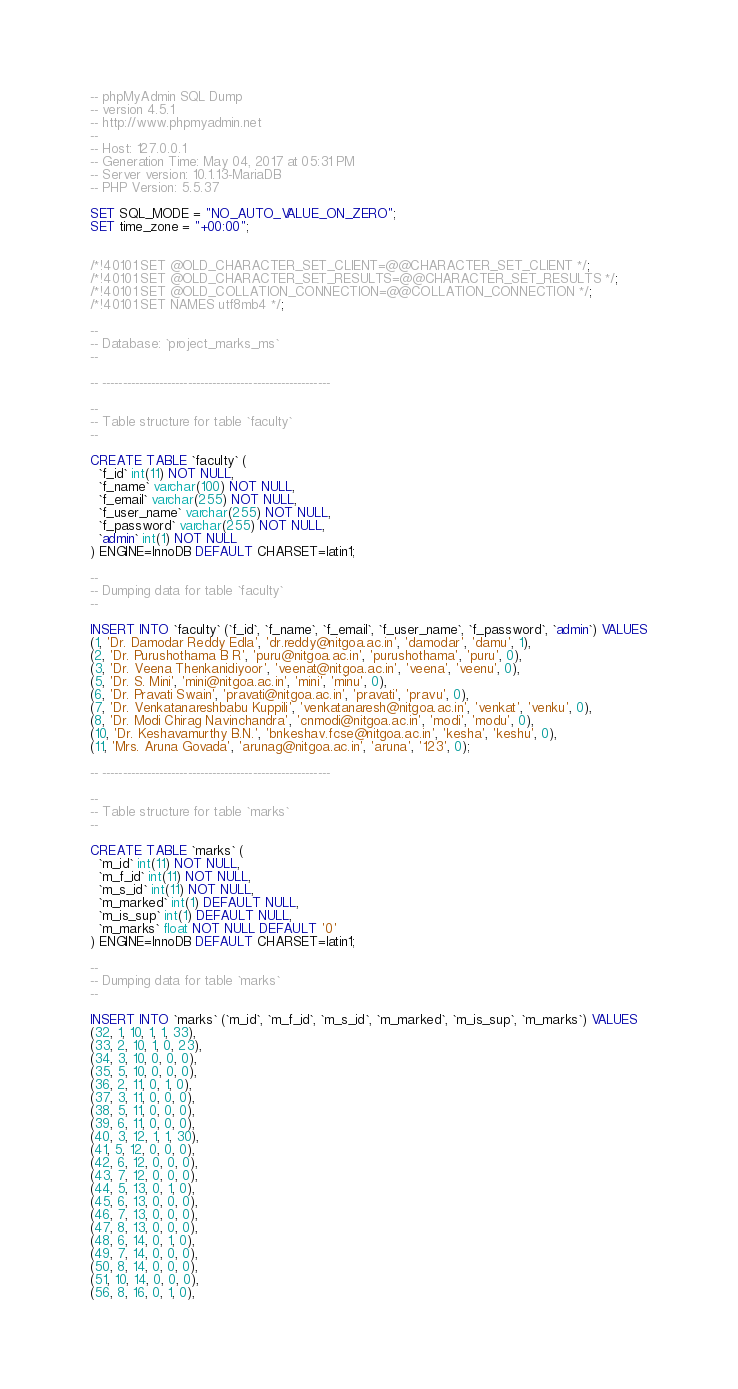Convert code to text. <code><loc_0><loc_0><loc_500><loc_500><_SQL_>-- phpMyAdmin SQL Dump
-- version 4.5.1
-- http://www.phpmyadmin.net
--
-- Host: 127.0.0.1
-- Generation Time: May 04, 2017 at 05:31 PM
-- Server version: 10.1.13-MariaDB
-- PHP Version: 5.5.37

SET SQL_MODE = "NO_AUTO_VALUE_ON_ZERO";
SET time_zone = "+00:00";


/*!40101 SET @OLD_CHARACTER_SET_CLIENT=@@CHARACTER_SET_CLIENT */;
/*!40101 SET @OLD_CHARACTER_SET_RESULTS=@@CHARACTER_SET_RESULTS */;
/*!40101 SET @OLD_COLLATION_CONNECTION=@@COLLATION_CONNECTION */;
/*!40101 SET NAMES utf8mb4 */;

--
-- Database: `project_marks_ms`
--

-- --------------------------------------------------------

--
-- Table structure for table `faculty`
--

CREATE TABLE `faculty` (
  `f_id` int(11) NOT NULL,
  `f_name` varchar(100) NOT NULL,
  `f_email` varchar(255) NOT NULL,
  `f_user_name` varchar(255) NOT NULL,
  `f_password` varchar(255) NOT NULL,
  `admin` int(1) NOT NULL
) ENGINE=InnoDB DEFAULT CHARSET=latin1;

--
-- Dumping data for table `faculty`
--

INSERT INTO `faculty` (`f_id`, `f_name`, `f_email`, `f_user_name`, `f_password`, `admin`) VALUES
(1, 'Dr. Damodar Reddy Edla', 'dr.reddy@nitgoa.ac.in', 'damodar', 'damu', 1),
(2, 'Dr. Purushothama B R', 'puru@nitgoa.ac.in', 'purushothama', 'puru', 0),
(3, 'Dr. Veena Thenkanidiyoor', 'veenat@nitgoa.ac.in', 'veena', 'veenu', 0),
(5, 'Dr. S. Mini', 'mini@nitgoa.ac.in', 'mini', 'minu', 0),
(6, 'Dr. Pravati Swain', 'pravati@nitgoa.ac.in', 'pravati', 'pravu', 0),
(7, 'Dr. Venkatanareshbabu Kuppili', 'venkatanaresh@nitgoa.ac.in', 'venkat', 'venku', 0),
(8, 'Dr. Modi Chirag Navinchandra', 'cnmodi@nitgoa.ac.in', 'modi', 'modu', 0),
(10, 'Dr. Keshavamurthy B.N.', 'bnkeshav.fcse@nitgoa.ac.in', 'kesha', 'keshu', 0),
(11, 'Mrs. Aruna Govada', 'arunag@nitgoa.ac.in', 'aruna', '123', 0);

-- --------------------------------------------------------

--
-- Table structure for table `marks`
--

CREATE TABLE `marks` (
  `m_id` int(11) NOT NULL,
  `m_f_id` int(11) NOT NULL,
  `m_s_id` int(11) NOT NULL,
  `m_marked` int(1) DEFAULT NULL,
  `m_is_sup` int(1) DEFAULT NULL,
  `m_marks` float NOT NULL DEFAULT '0'
) ENGINE=InnoDB DEFAULT CHARSET=latin1;

--
-- Dumping data for table `marks`
--

INSERT INTO `marks` (`m_id`, `m_f_id`, `m_s_id`, `m_marked`, `m_is_sup`, `m_marks`) VALUES
(32, 1, 10, 1, 1, 33),
(33, 2, 10, 1, 0, 23),
(34, 3, 10, 0, 0, 0),
(35, 5, 10, 0, 0, 0),
(36, 2, 11, 0, 1, 0),
(37, 3, 11, 0, 0, 0),
(38, 5, 11, 0, 0, 0),
(39, 6, 11, 0, 0, 0),
(40, 3, 12, 1, 1, 30),
(41, 5, 12, 0, 0, 0),
(42, 6, 12, 0, 0, 0),
(43, 7, 12, 0, 0, 0),
(44, 5, 13, 0, 1, 0),
(45, 6, 13, 0, 0, 0),
(46, 7, 13, 0, 0, 0),
(47, 8, 13, 0, 0, 0),
(48, 6, 14, 0, 1, 0),
(49, 7, 14, 0, 0, 0),
(50, 8, 14, 0, 0, 0),
(51, 10, 14, 0, 0, 0),
(56, 8, 16, 0, 1, 0),</code> 